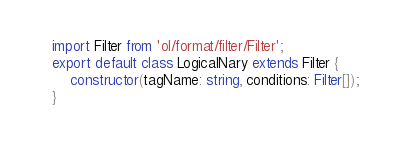<code> <loc_0><loc_0><loc_500><loc_500><_TypeScript_>import Filter from 'ol/format/filter/Filter';
export default class LogicalNary extends Filter {
    constructor(tagName: string, conditions: Filter[]);
}
</code> 